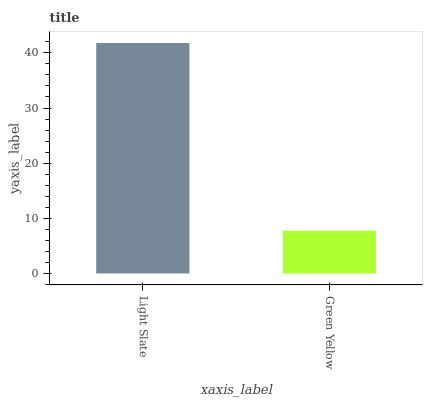Is Green Yellow the minimum?
Answer yes or no. Yes. Is Light Slate the maximum?
Answer yes or no. Yes. Is Green Yellow the maximum?
Answer yes or no. No. Is Light Slate greater than Green Yellow?
Answer yes or no. Yes. Is Green Yellow less than Light Slate?
Answer yes or no. Yes. Is Green Yellow greater than Light Slate?
Answer yes or no. No. Is Light Slate less than Green Yellow?
Answer yes or no. No. Is Light Slate the high median?
Answer yes or no. Yes. Is Green Yellow the low median?
Answer yes or no. Yes. Is Green Yellow the high median?
Answer yes or no. No. Is Light Slate the low median?
Answer yes or no. No. 